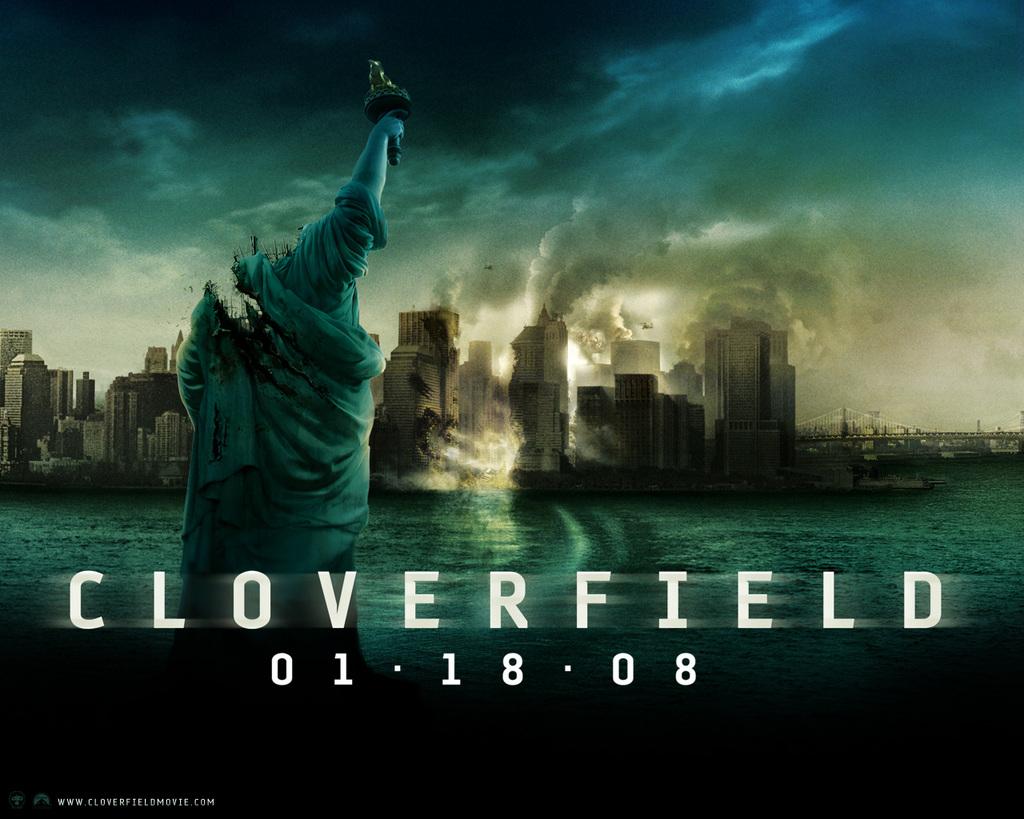What date will this movie be released?
Offer a very short reply. 01-18-08. What is the website at the corner?
Provide a short and direct response. Www.cloverfieldmovie.com. 